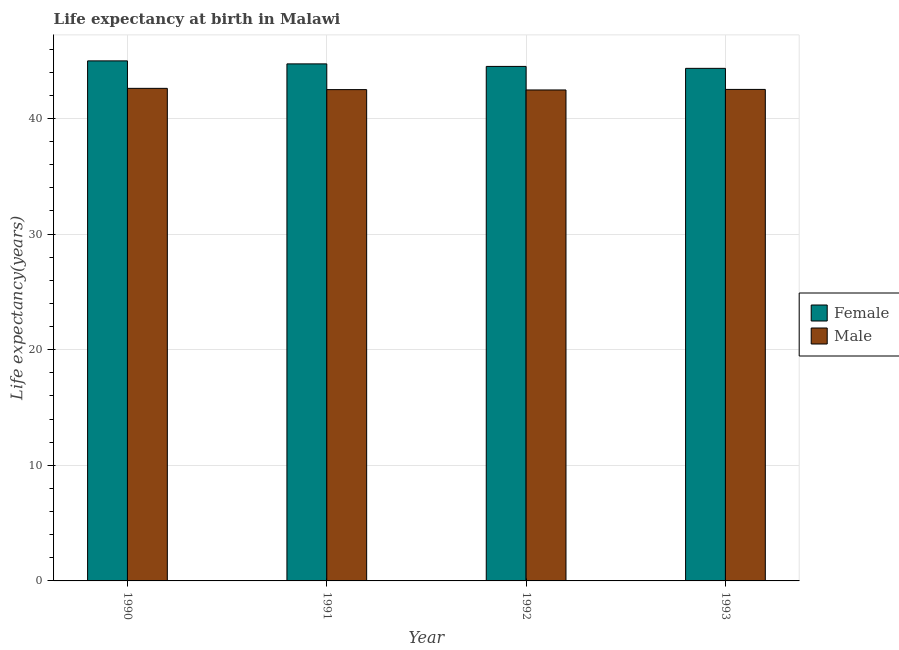How many different coloured bars are there?
Ensure brevity in your answer.  2. How many groups of bars are there?
Your response must be concise. 4. Are the number of bars per tick equal to the number of legend labels?
Keep it short and to the point. Yes. Are the number of bars on each tick of the X-axis equal?
Your response must be concise. Yes. How many bars are there on the 4th tick from the left?
Keep it short and to the point. 2. How many bars are there on the 3rd tick from the right?
Your response must be concise. 2. What is the label of the 2nd group of bars from the left?
Your answer should be compact. 1991. What is the life expectancy(female) in 1990?
Make the answer very short. 44.98. Across all years, what is the maximum life expectancy(female)?
Keep it short and to the point. 44.98. Across all years, what is the minimum life expectancy(male)?
Make the answer very short. 42.47. In which year was the life expectancy(male) minimum?
Offer a terse response. 1992. What is the total life expectancy(male) in the graph?
Ensure brevity in your answer.  170.09. What is the difference between the life expectancy(female) in 1992 and that in 1993?
Provide a succinct answer. 0.17. What is the difference between the life expectancy(female) in 1992 and the life expectancy(male) in 1991?
Ensure brevity in your answer.  -0.22. What is the average life expectancy(female) per year?
Your answer should be compact. 44.64. In the year 1992, what is the difference between the life expectancy(male) and life expectancy(female)?
Your answer should be compact. 0. What is the ratio of the life expectancy(male) in 1990 to that in 1992?
Offer a very short reply. 1. Is the difference between the life expectancy(female) in 1990 and 1992 greater than the difference between the life expectancy(male) in 1990 and 1992?
Your response must be concise. No. What is the difference between the highest and the second highest life expectancy(male)?
Ensure brevity in your answer.  0.09. What is the difference between the highest and the lowest life expectancy(male)?
Provide a succinct answer. 0.14. In how many years, is the life expectancy(female) greater than the average life expectancy(female) taken over all years?
Offer a terse response. 2. Is the sum of the life expectancy(female) in 1991 and 1993 greater than the maximum life expectancy(male) across all years?
Your response must be concise. Yes. What does the 2nd bar from the left in 1993 represents?
Provide a short and direct response. Male. How many bars are there?
Keep it short and to the point. 8. Are all the bars in the graph horizontal?
Give a very brief answer. No. Does the graph contain any zero values?
Offer a very short reply. No. Does the graph contain grids?
Provide a short and direct response. Yes. How many legend labels are there?
Offer a very short reply. 2. What is the title of the graph?
Offer a terse response. Life expectancy at birth in Malawi. Does "Male population" appear as one of the legend labels in the graph?
Offer a very short reply. No. What is the label or title of the X-axis?
Make the answer very short. Year. What is the label or title of the Y-axis?
Your answer should be very brief. Life expectancy(years). What is the Life expectancy(years) of Female in 1990?
Your answer should be compact. 44.98. What is the Life expectancy(years) in Male in 1990?
Provide a short and direct response. 42.61. What is the Life expectancy(years) in Female in 1991?
Offer a terse response. 44.72. What is the Life expectancy(years) of Male in 1991?
Offer a very short reply. 42.5. What is the Life expectancy(years) of Female in 1992?
Provide a succinct answer. 44.5. What is the Life expectancy(years) in Male in 1992?
Provide a succinct answer. 42.47. What is the Life expectancy(years) of Female in 1993?
Keep it short and to the point. 44.34. What is the Life expectancy(years) in Male in 1993?
Your answer should be very brief. 42.52. Across all years, what is the maximum Life expectancy(years) of Female?
Ensure brevity in your answer.  44.98. Across all years, what is the maximum Life expectancy(years) of Male?
Keep it short and to the point. 42.61. Across all years, what is the minimum Life expectancy(years) in Female?
Ensure brevity in your answer.  44.34. Across all years, what is the minimum Life expectancy(years) of Male?
Provide a short and direct response. 42.47. What is the total Life expectancy(years) in Female in the graph?
Offer a terse response. 178.55. What is the total Life expectancy(years) in Male in the graph?
Ensure brevity in your answer.  170.09. What is the difference between the Life expectancy(years) in Female in 1990 and that in 1991?
Offer a terse response. 0.26. What is the difference between the Life expectancy(years) of Male in 1990 and that in 1991?
Your answer should be very brief. 0.11. What is the difference between the Life expectancy(years) of Female in 1990 and that in 1992?
Offer a very short reply. 0.48. What is the difference between the Life expectancy(years) of Male in 1990 and that in 1992?
Your answer should be compact. 0.14. What is the difference between the Life expectancy(years) in Female in 1990 and that in 1993?
Offer a terse response. 0.65. What is the difference between the Life expectancy(years) in Male in 1990 and that in 1993?
Provide a short and direct response. 0.09. What is the difference between the Life expectancy(years) of Female in 1991 and that in 1992?
Your answer should be compact. 0.22. What is the difference between the Life expectancy(years) in Male in 1991 and that in 1992?
Provide a succinct answer. 0.03. What is the difference between the Life expectancy(years) of Female in 1991 and that in 1993?
Your answer should be compact. 0.39. What is the difference between the Life expectancy(years) in Male in 1991 and that in 1993?
Make the answer very short. -0.02. What is the difference between the Life expectancy(years) in Female in 1992 and that in 1993?
Offer a very short reply. 0.17. What is the difference between the Life expectancy(years) of Male in 1992 and that in 1993?
Keep it short and to the point. -0.05. What is the difference between the Life expectancy(years) in Female in 1990 and the Life expectancy(years) in Male in 1991?
Provide a succinct answer. 2.49. What is the difference between the Life expectancy(years) in Female in 1990 and the Life expectancy(years) in Male in 1992?
Offer a very short reply. 2.52. What is the difference between the Life expectancy(years) of Female in 1990 and the Life expectancy(years) of Male in 1993?
Ensure brevity in your answer.  2.47. What is the difference between the Life expectancy(years) in Female in 1991 and the Life expectancy(years) in Male in 1992?
Offer a very short reply. 2.26. What is the difference between the Life expectancy(years) in Female in 1991 and the Life expectancy(years) in Male in 1993?
Your answer should be very brief. 2.21. What is the difference between the Life expectancy(years) of Female in 1992 and the Life expectancy(years) of Male in 1993?
Your response must be concise. 1.99. What is the average Life expectancy(years) of Female per year?
Your answer should be very brief. 44.64. What is the average Life expectancy(years) of Male per year?
Provide a succinct answer. 42.52. In the year 1990, what is the difference between the Life expectancy(years) in Female and Life expectancy(years) in Male?
Your answer should be very brief. 2.38. In the year 1991, what is the difference between the Life expectancy(years) of Female and Life expectancy(years) of Male?
Provide a succinct answer. 2.23. In the year 1992, what is the difference between the Life expectancy(years) in Female and Life expectancy(years) in Male?
Your answer should be very brief. 2.04. In the year 1993, what is the difference between the Life expectancy(years) of Female and Life expectancy(years) of Male?
Offer a terse response. 1.82. What is the ratio of the Life expectancy(years) in Female in 1990 to that in 1991?
Your response must be concise. 1.01. What is the ratio of the Life expectancy(years) of Male in 1990 to that in 1991?
Offer a very short reply. 1. What is the ratio of the Life expectancy(years) in Female in 1990 to that in 1992?
Provide a short and direct response. 1.01. What is the ratio of the Life expectancy(years) of Male in 1990 to that in 1992?
Make the answer very short. 1. What is the ratio of the Life expectancy(years) of Female in 1990 to that in 1993?
Provide a short and direct response. 1.01. What is the ratio of the Life expectancy(years) of Male in 1990 to that in 1993?
Your answer should be compact. 1. What is the ratio of the Life expectancy(years) of Female in 1991 to that in 1992?
Offer a terse response. 1. What is the ratio of the Life expectancy(years) in Female in 1991 to that in 1993?
Give a very brief answer. 1.01. What is the ratio of the Life expectancy(years) of Male in 1992 to that in 1993?
Provide a short and direct response. 1. What is the difference between the highest and the second highest Life expectancy(years) of Female?
Make the answer very short. 0.26. What is the difference between the highest and the second highest Life expectancy(years) of Male?
Offer a very short reply. 0.09. What is the difference between the highest and the lowest Life expectancy(years) in Female?
Provide a short and direct response. 0.65. What is the difference between the highest and the lowest Life expectancy(years) in Male?
Give a very brief answer. 0.14. 